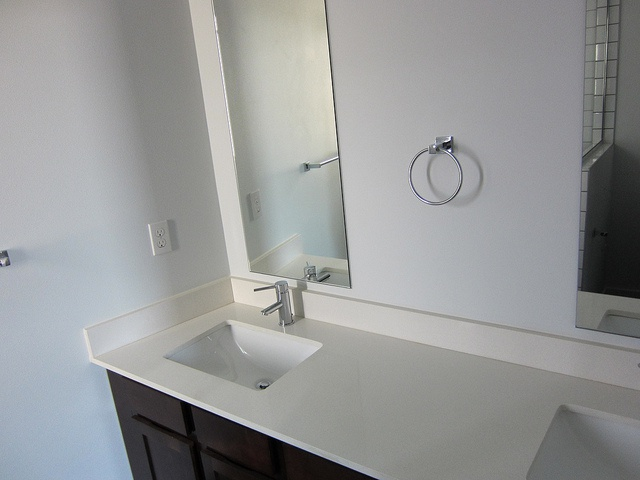Describe the objects in this image and their specific colors. I can see sink in gray tones and sink in gray, darkgray, and lightgray tones in this image. 